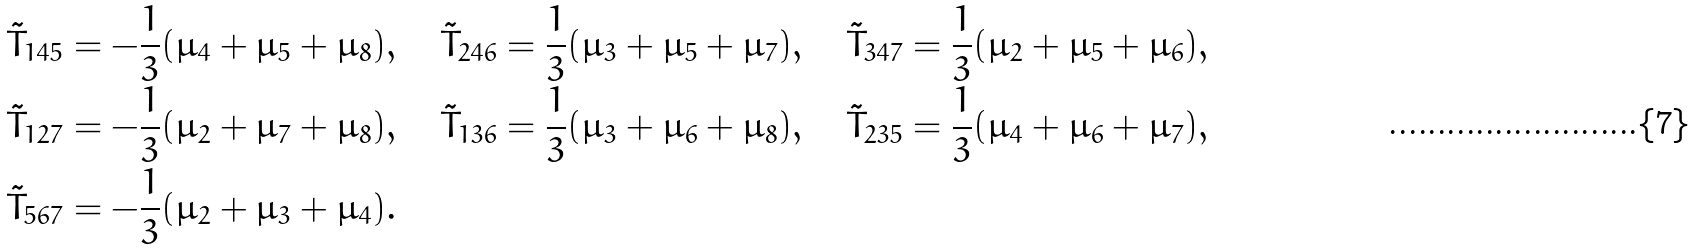<formula> <loc_0><loc_0><loc_500><loc_500>& \tilde { T } _ { 1 4 5 } = - \frac { 1 } { 3 } ( \mu _ { 4 } + \mu _ { 5 } + \mu _ { 8 } ) , \quad \tilde { T } _ { 2 4 6 } = \frac { 1 } { 3 } ( \mu _ { 3 } + \mu _ { 5 } + \mu _ { 7 } ) , \quad \tilde { T } _ { 3 4 7 } = \frac { 1 } { 3 } ( \mu _ { 2 } + \mu _ { 5 } + \mu _ { 6 } ) , \\ & \tilde { T } _ { 1 2 7 } = - \frac { 1 } { 3 } ( \mu _ { 2 } + \mu _ { 7 } + \mu _ { 8 } ) , \quad \tilde { T } _ { 1 3 6 } = \frac { 1 } { 3 } ( \mu _ { 3 } + \mu _ { 6 } + \mu _ { 8 } ) , \quad \tilde { T } _ { 2 3 5 } = \frac { 1 } { 3 } ( \mu _ { 4 } + \mu _ { 6 } + \mu _ { 7 } ) , \\ & \tilde { T } _ { 5 6 7 } = - \frac { 1 } { 3 } ( \mu _ { 2 } + \mu _ { 3 } + \mu _ { 4 } ) .</formula> 